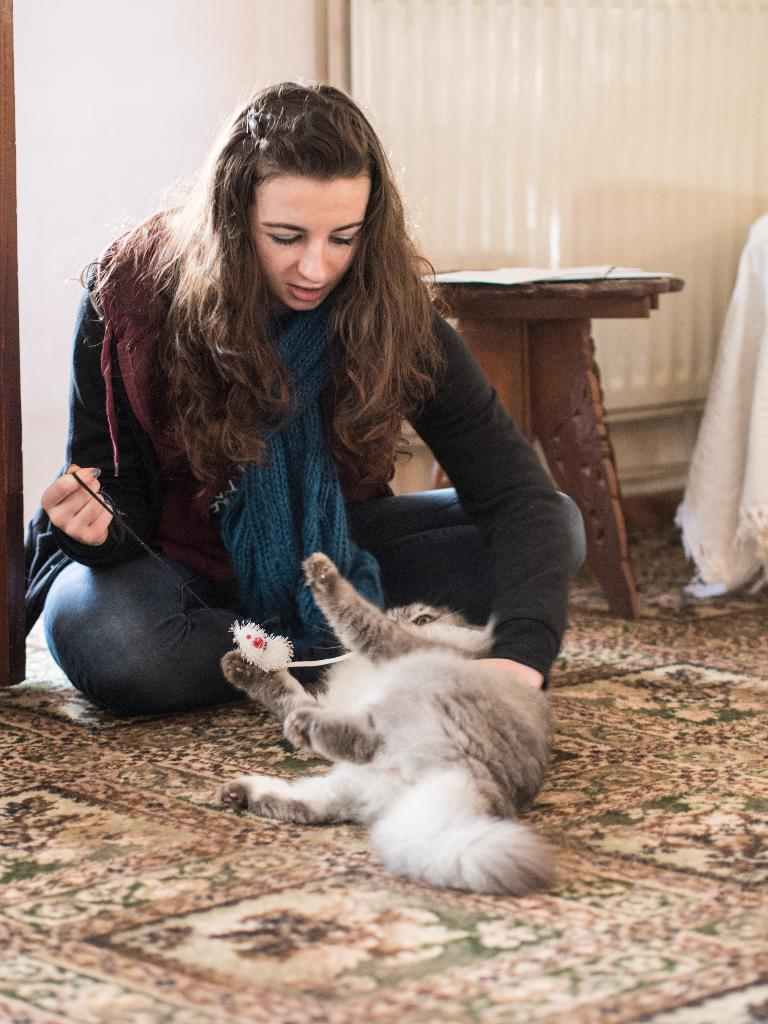Who is the main subject in the image? There is a woman in the image. What is the woman holding in the image? The woman is holding a cat. What can be seen in the background of the image? There is a curtain in the background of the image. What type of punishment is the woman receiving in the image? There is no indication of punishment in the image; the woman is holding a cat. 